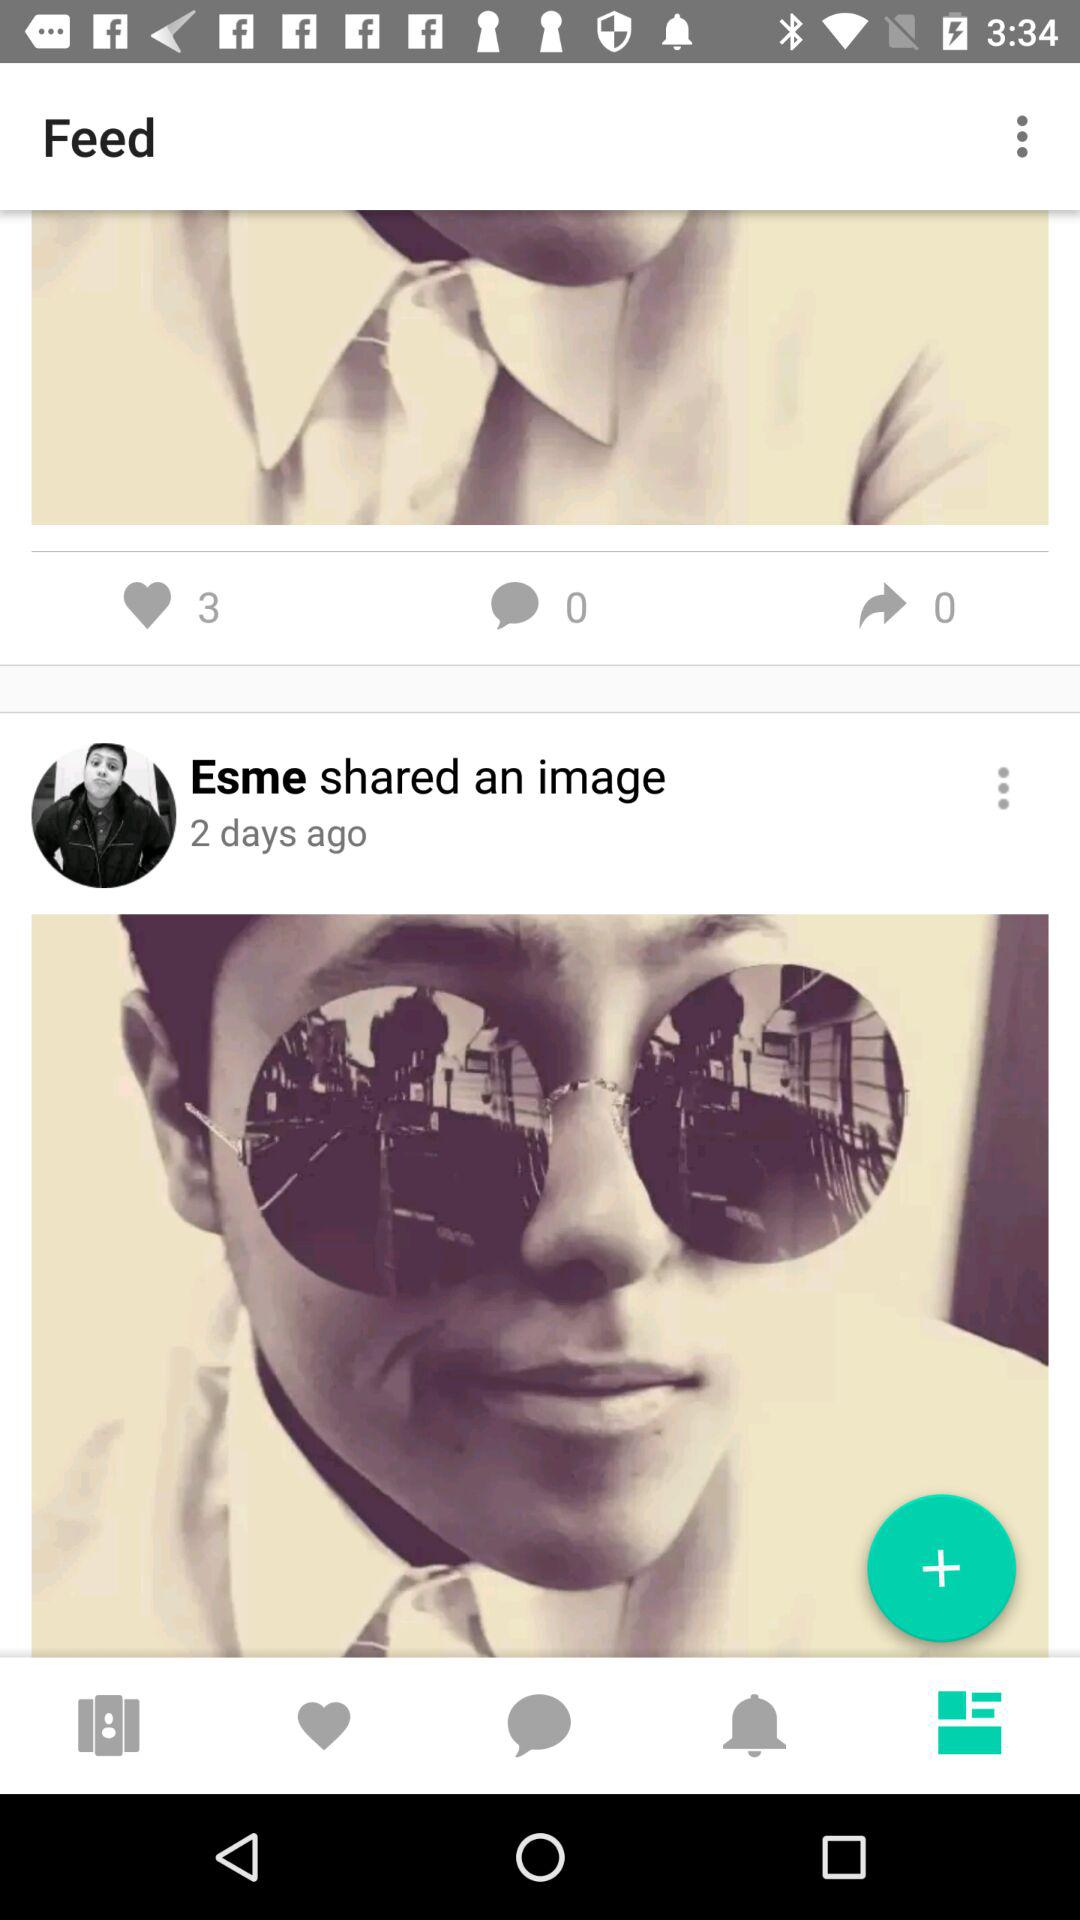When did Esme share an image? Esme shared an image 2 days ago. 